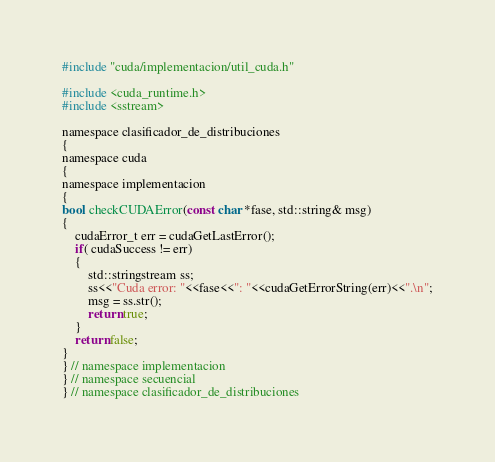Convert code to text. <code><loc_0><loc_0><loc_500><loc_500><_Cuda_>#include "cuda/implementacion/util_cuda.h"

#include <cuda_runtime.h>
#include <sstream>

namespace clasificador_de_distribuciones
{
namespace cuda
{
namespace implementacion
{
bool checkCUDAError(const char *fase, std::string& msg)
{
    cudaError_t err = cudaGetLastError();
    if( cudaSuccess != err)
    {
        std::stringstream ss;
        ss<<"Cuda error: "<<fase<<": "<<cudaGetErrorString(err)<<".\n";
        msg = ss.str();
        return true;
    }
    return false;
}
} // namespace implementacion
} // namespace secuencial
} // namespace clasificador_de_distribuciones</code> 